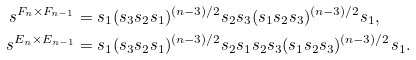Convert formula to latex. <formula><loc_0><loc_0><loc_500><loc_500>s ^ { F _ { n } \times F _ { n - 1 } } & = s _ { 1 } ( s _ { 3 } s _ { 2 } s _ { 1 } ) ^ { ( n - 3 ) / 2 } s _ { 2 } s _ { 3 } ( s _ { 1 } s _ { 2 } s _ { 3 } ) ^ { ( n - 3 ) / 2 } s _ { 1 } , \ \\ s ^ { E _ { n } \times E _ { n - 1 } } & = s _ { 1 } ( s _ { 3 } s _ { 2 } s _ { 1 } ) ^ { ( n - 3 ) / 2 } s _ { 2 } s _ { 1 } s _ { 2 } s _ { 3 } ( s _ { 1 } s _ { 2 } s _ { 3 } ) ^ { ( n - 3 ) / 2 } s _ { 1 } .</formula> 